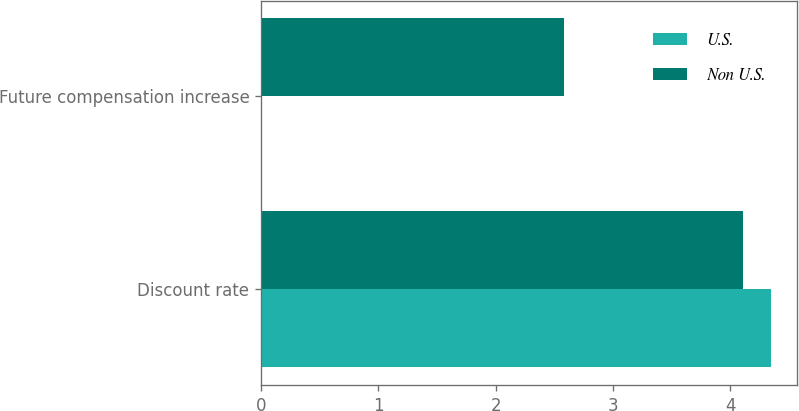Convert chart. <chart><loc_0><loc_0><loc_500><loc_500><stacked_bar_chart><ecel><fcel>Discount rate<fcel>Future compensation increase<nl><fcel>U.S.<fcel>4.35<fcel>0<nl><fcel>Non U.S.<fcel>4.11<fcel>2.58<nl></chart> 